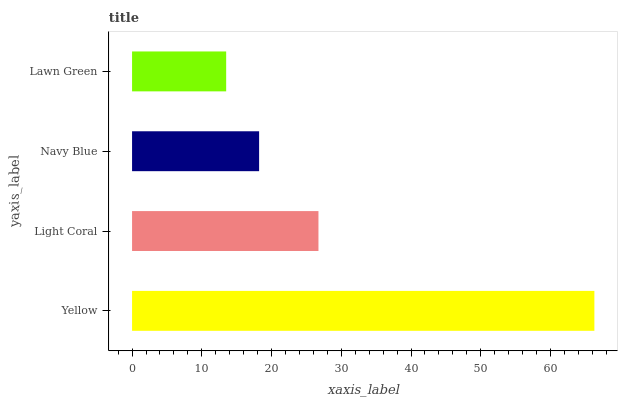Is Lawn Green the minimum?
Answer yes or no. Yes. Is Yellow the maximum?
Answer yes or no. Yes. Is Light Coral the minimum?
Answer yes or no. No. Is Light Coral the maximum?
Answer yes or no. No. Is Yellow greater than Light Coral?
Answer yes or no. Yes. Is Light Coral less than Yellow?
Answer yes or no. Yes. Is Light Coral greater than Yellow?
Answer yes or no. No. Is Yellow less than Light Coral?
Answer yes or no. No. Is Light Coral the high median?
Answer yes or no. Yes. Is Navy Blue the low median?
Answer yes or no. Yes. Is Navy Blue the high median?
Answer yes or no. No. Is Yellow the low median?
Answer yes or no. No. 